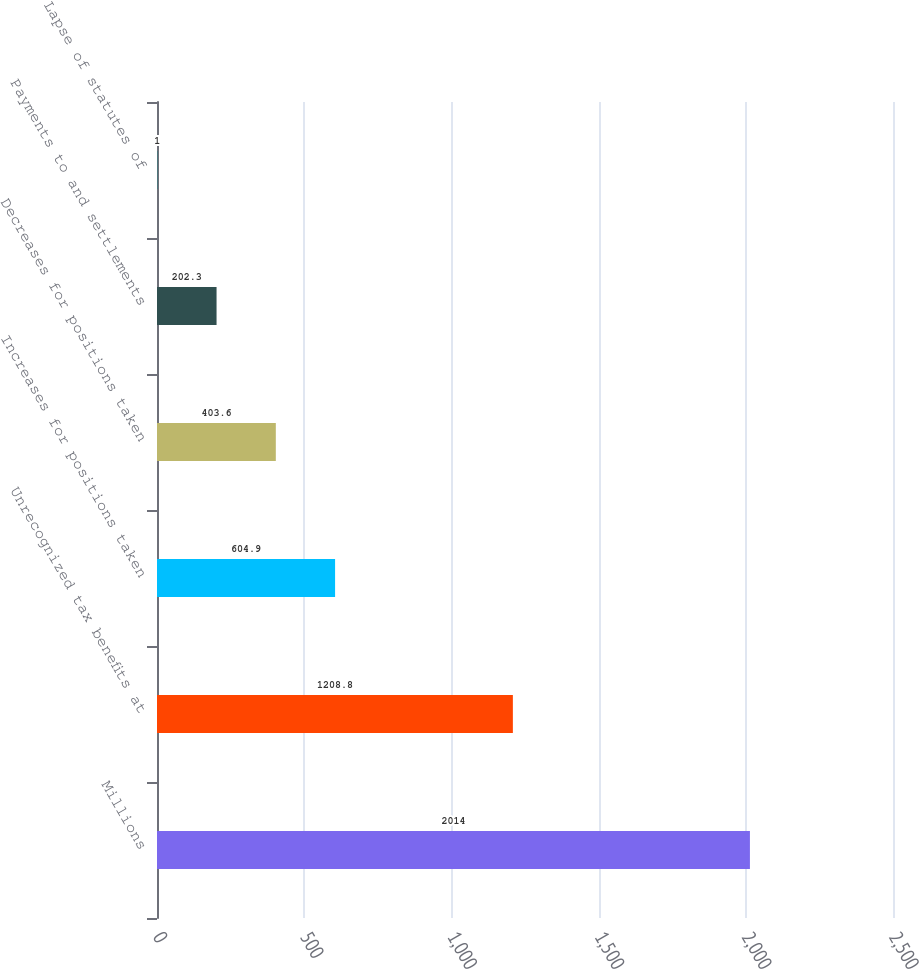Convert chart. <chart><loc_0><loc_0><loc_500><loc_500><bar_chart><fcel>Millions<fcel>Unrecognized tax benefits at<fcel>Increases for positions taken<fcel>Decreases for positions taken<fcel>Payments to and settlements<fcel>Lapse of statutes of<nl><fcel>2014<fcel>1208.8<fcel>604.9<fcel>403.6<fcel>202.3<fcel>1<nl></chart> 